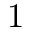Convert formula to latex. <formula><loc_0><loc_0><loc_500><loc_500>1</formula> 